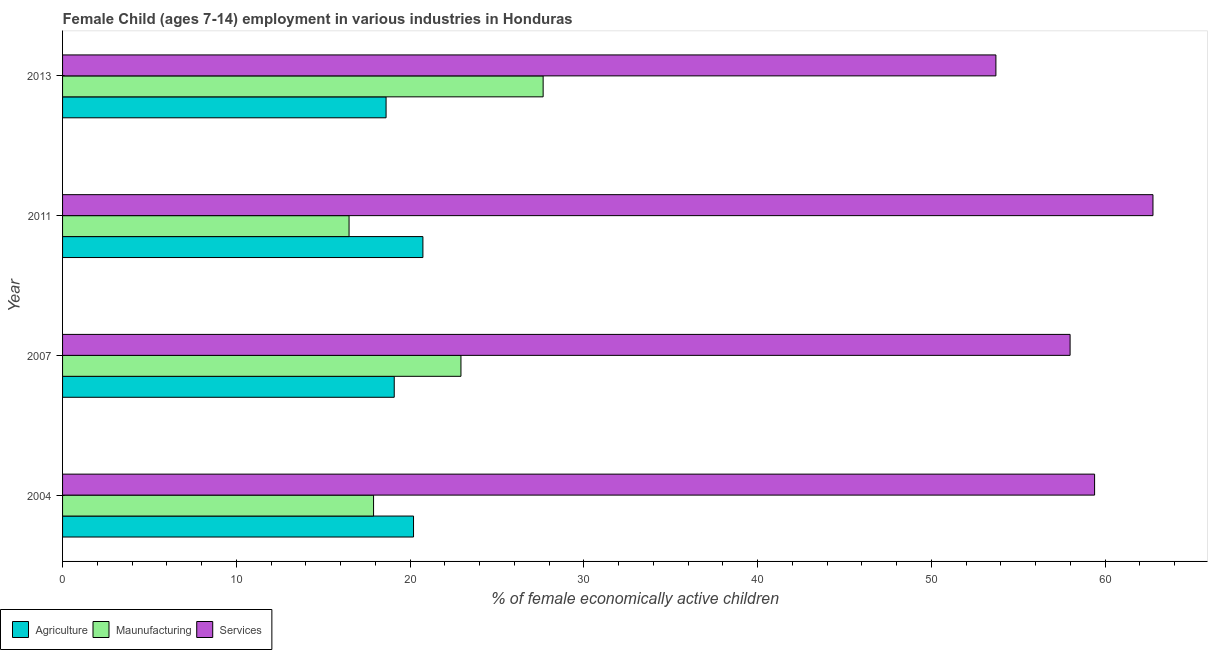How many different coloured bars are there?
Keep it short and to the point. 3. In how many cases, is the number of bars for a given year not equal to the number of legend labels?
Ensure brevity in your answer.  0. What is the percentage of economically active children in services in 2007?
Keep it short and to the point. 57.99. Across all years, what is the maximum percentage of economically active children in agriculture?
Offer a terse response. 20.74. Across all years, what is the minimum percentage of economically active children in agriculture?
Make the answer very short. 18.62. In which year was the percentage of economically active children in manufacturing maximum?
Offer a very short reply. 2013. In which year was the percentage of economically active children in services minimum?
Ensure brevity in your answer.  2013. What is the total percentage of economically active children in services in the graph?
Your answer should be compact. 233.87. What is the difference between the percentage of economically active children in services in 2007 and that in 2011?
Provide a succinct answer. -4.77. What is the difference between the percentage of economically active children in services in 2007 and the percentage of economically active children in manufacturing in 2011?
Keep it short and to the point. 41.5. What is the average percentage of economically active children in manufacturing per year?
Your response must be concise. 21.25. In the year 2007, what is the difference between the percentage of economically active children in agriculture and percentage of economically active children in services?
Give a very brief answer. -38.9. In how many years, is the percentage of economically active children in services greater than 44 %?
Your answer should be compact. 4. What is the ratio of the percentage of economically active children in manufacturing in 2007 to that in 2013?
Your answer should be very brief. 0.83. Is the percentage of economically active children in agriculture in 2011 less than that in 2013?
Provide a short and direct response. No. Is the difference between the percentage of economically active children in agriculture in 2004 and 2011 greater than the difference between the percentage of economically active children in services in 2004 and 2011?
Provide a short and direct response. Yes. What is the difference between the highest and the second highest percentage of economically active children in services?
Provide a short and direct response. 3.36. What is the difference between the highest and the lowest percentage of economically active children in services?
Keep it short and to the point. 9.04. In how many years, is the percentage of economically active children in agriculture greater than the average percentage of economically active children in agriculture taken over all years?
Your answer should be very brief. 2. What does the 2nd bar from the top in 2004 represents?
Provide a short and direct response. Maunufacturing. What does the 3rd bar from the bottom in 2007 represents?
Give a very brief answer. Services. Is it the case that in every year, the sum of the percentage of economically active children in agriculture and percentage of economically active children in manufacturing is greater than the percentage of economically active children in services?
Make the answer very short. No. How many bars are there?
Give a very brief answer. 12. Where does the legend appear in the graph?
Your answer should be compact. Bottom left. How many legend labels are there?
Provide a short and direct response. 3. What is the title of the graph?
Offer a very short reply. Female Child (ages 7-14) employment in various industries in Honduras. What is the label or title of the X-axis?
Keep it short and to the point. % of female economically active children. What is the % of female economically active children in Agriculture in 2004?
Provide a short and direct response. 20.2. What is the % of female economically active children in Services in 2004?
Offer a very short reply. 59.4. What is the % of female economically active children in Agriculture in 2007?
Ensure brevity in your answer.  19.09. What is the % of female economically active children of Maunufacturing in 2007?
Give a very brief answer. 22.93. What is the % of female economically active children in Services in 2007?
Your answer should be compact. 57.99. What is the % of female economically active children of Agriculture in 2011?
Keep it short and to the point. 20.74. What is the % of female economically active children of Maunufacturing in 2011?
Ensure brevity in your answer.  16.49. What is the % of female economically active children of Services in 2011?
Offer a very short reply. 62.76. What is the % of female economically active children of Agriculture in 2013?
Your answer should be compact. 18.62. What is the % of female economically active children in Maunufacturing in 2013?
Offer a very short reply. 27.66. What is the % of female economically active children in Services in 2013?
Ensure brevity in your answer.  53.72. Across all years, what is the maximum % of female economically active children of Agriculture?
Make the answer very short. 20.74. Across all years, what is the maximum % of female economically active children of Maunufacturing?
Offer a terse response. 27.66. Across all years, what is the maximum % of female economically active children in Services?
Your answer should be compact. 62.76. Across all years, what is the minimum % of female economically active children of Agriculture?
Make the answer very short. 18.62. Across all years, what is the minimum % of female economically active children in Maunufacturing?
Offer a very short reply. 16.49. Across all years, what is the minimum % of female economically active children in Services?
Provide a short and direct response. 53.72. What is the total % of female economically active children in Agriculture in the graph?
Give a very brief answer. 78.65. What is the total % of female economically active children in Maunufacturing in the graph?
Offer a terse response. 84.98. What is the total % of female economically active children in Services in the graph?
Offer a very short reply. 233.87. What is the difference between the % of female economically active children in Agriculture in 2004 and that in 2007?
Your response must be concise. 1.11. What is the difference between the % of female economically active children in Maunufacturing in 2004 and that in 2007?
Give a very brief answer. -5.03. What is the difference between the % of female economically active children of Services in 2004 and that in 2007?
Provide a succinct answer. 1.41. What is the difference between the % of female economically active children of Agriculture in 2004 and that in 2011?
Offer a very short reply. -0.54. What is the difference between the % of female economically active children in Maunufacturing in 2004 and that in 2011?
Your answer should be very brief. 1.41. What is the difference between the % of female economically active children of Services in 2004 and that in 2011?
Your answer should be compact. -3.36. What is the difference between the % of female economically active children of Agriculture in 2004 and that in 2013?
Your answer should be compact. 1.58. What is the difference between the % of female economically active children of Maunufacturing in 2004 and that in 2013?
Offer a terse response. -9.76. What is the difference between the % of female economically active children in Services in 2004 and that in 2013?
Make the answer very short. 5.68. What is the difference between the % of female economically active children in Agriculture in 2007 and that in 2011?
Provide a short and direct response. -1.65. What is the difference between the % of female economically active children in Maunufacturing in 2007 and that in 2011?
Ensure brevity in your answer.  6.44. What is the difference between the % of female economically active children in Services in 2007 and that in 2011?
Offer a terse response. -4.77. What is the difference between the % of female economically active children of Agriculture in 2007 and that in 2013?
Ensure brevity in your answer.  0.47. What is the difference between the % of female economically active children of Maunufacturing in 2007 and that in 2013?
Your answer should be very brief. -4.73. What is the difference between the % of female economically active children in Services in 2007 and that in 2013?
Your answer should be very brief. 4.27. What is the difference between the % of female economically active children in Agriculture in 2011 and that in 2013?
Make the answer very short. 2.12. What is the difference between the % of female economically active children of Maunufacturing in 2011 and that in 2013?
Offer a terse response. -11.17. What is the difference between the % of female economically active children of Services in 2011 and that in 2013?
Give a very brief answer. 9.04. What is the difference between the % of female economically active children of Agriculture in 2004 and the % of female economically active children of Maunufacturing in 2007?
Offer a very short reply. -2.73. What is the difference between the % of female economically active children in Agriculture in 2004 and the % of female economically active children in Services in 2007?
Give a very brief answer. -37.79. What is the difference between the % of female economically active children in Maunufacturing in 2004 and the % of female economically active children in Services in 2007?
Keep it short and to the point. -40.09. What is the difference between the % of female economically active children of Agriculture in 2004 and the % of female economically active children of Maunufacturing in 2011?
Make the answer very short. 3.71. What is the difference between the % of female economically active children in Agriculture in 2004 and the % of female economically active children in Services in 2011?
Ensure brevity in your answer.  -42.56. What is the difference between the % of female economically active children in Maunufacturing in 2004 and the % of female economically active children in Services in 2011?
Make the answer very short. -44.86. What is the difference between the % of female economically active children in Agriculture in 2004 and the % of female economically active children in Maunufacturing in 2013?
Your answer should be compact. -7.46. What is the difference between the % of female economically active children of Agriculture in 2004 and the % of female economically active children of Services in 2013?
Offer a very short reply. -33.52. What is the difference between the % of female economically active children of Maunufacturing in 2004 and the % of female economically active children of Services in 2013?
Provide a short and direct response. -35.82. What is the difference between the % of female economically active children of Agriculture in 2007 and the % of female economically active children of Maunufacturing in 2011?
Keep it short and to the point. 2.6. What is the difference between the % of female economically active children of Agriculture in 2007 and the % of female economically active children of Services in 2011?
Offer a terse response. -43.67. What is the difference between the % of female economically active children of Maunufacturing in 2007 and the % of female economically active children of Services in 2011?
Your response must be concise. -39.83. What is the difference between the % of female economically active children in Agriculture in 2007 and the % of female economically active children in Maunufacturing in 2013?
Keep it short and to the point. -8.57. What is the difference between the % of female economically active children of Agriculture in 2007 and the % of female economically active children of Services in 2013?
Your answer should be compact. -34.63. What is the difference between the % of female economically active children in Maunufacturing in 2007 and the % of female economically active children in Services in 2013?
Provide a short and direct response. -30.79. What is the difference between the % of female economically active children of Agriculture in 2011 and the % of female economically active children of Maunufacturing in 2013?
Provide a short and direct response. -6.92. What is the difference between the % of female economically active children in Agriculture in 2011 and the % of female economically active children in Services in 2013?
Provide a short and direct response. -32.98. What is the difference between the % of female economically active children in Maunufacturing in 2011 and the % of female economically active children in Services in 2013?
Offer a terse response. -37.23. What is the average % of female economically active children of Agriculture per year?
Offer a terse response. 19.66. What is the average % of female economically active children in Maunufacturing per year?
Provide a succinct answer. 21.25. What is the average % of female economically active children of Services per year?
Provide a succinct answer. 58.47. In the year 2004, what is the difference between the % of female economically active children in Agriculture and % of female economically active children in Maunufacturing?
Provide a succinct answer. 2.3. In the year 2004, what is the difference between the % of female economically active children in Agriculture and % of female economically active children in Services?
Ensure brevity in your answer.  -39.2. In the year 2004, what is the difference between the % of female economically active children in Maunufacturing and % of female economically active children in Services?
Make the answer very short. -41.5. In the year 2007, what is the difference between the % of female economically active children of Agriculture and % of female economically active children of Maunufacturing?
Keep it short and to the point. -3.84. In the year 2007, what is the difference between the % of female economically active children in Agriculture and % of female economically active children in Services?
Your answer should be compact. -38.9. In the year 2007, what is the difference between the % of female economically active children in Maunufacturing and % of female economically active children in Services?
Keep it short and to the point. -35.06. In the year 2011, what is the difference between the % of female economically active children of Agriculture and % of female economically active children of Maunufacturing?
Offer a very short reply. 4.25. In the year 2011, what is the difference between the % of female economically active children of Agriculture and % of female economically active children of Services?
Offer a terse response. -42.02. In the year 2011, what is the difference between the % of female economically active children of Maunufacturing and % of female economically active children of Services?
Offer a very short reply. -46.27. In the year 2013, what is the difference between the % of female economically active children of Agriculture and % of female economically active children of Maunufacturing?
Your answer should be very brief. -9.04. In the year 2013, what is the difference between the % of female economically active children of Agriculture and % of female economically active children of Services?
Give a very brief answer. -35.1. In the year 2013, what is the difference between the % of female economically active children in Maunufacturing and % of female economically active children in Services?
Your answer should be compact. -26.06. What is the ratio of the % of female economically active children of Agriculture in 2004 to that in 2007?
Make the answer very short. 1.06. What is the ratio of the % of female economically active children in Maunufacturing in 2004 to that in 2007?
Your answer should be very brief. 0.78. What is the ratio of the % of female economically active children of Services in 2004 to that in 2007?
Provide a succinct answer. 1.02. What is the ratio of the % of female economically active children of Agriculture in 2004 to that in 2011?
Your response must be concise. 0.97. What is the ratio of the % of female economically active children in Maunufacturing in 2004 to that in 2011?
Make the answer very short. 1.09. What is the ratio of the % of female economically active children of Services in 2004 to that in 2011?
Your answer should be very brief. 0.95. What is the ratio of the % of female economically active children of Agriculture in 2004 to that in 2013?
Your answer should be very brief. 1.08. What is the ratio of the % of female economically active children of Maunufacturing in 2004 to that in 2013?
Your answer should be compact. 0.65. What is the ratio of the % of female economically active children of Services in 2004 to that in 2013?
Offer a very short reply. 1.11. What is the ratio of the % of female economically active children of Agriculture in 2007 to that in 2011?
Keep it short and to the point. 0.92. What is the ratio of the % of female economically active children in Maunufacturing in 2007 to that in 2011?
Make the answer very short. 1.39. What is the ratio of the % of female economically active children of Services in 2007 to that in 2011?
Keep it short and to the point. 0.92. What is the ratio of the % of female economically active children of Agriculture in 2007 to that in 2013?
Give a very brief answer. 1.03. What is the ratio of the % of female economically active children of Maunufacturing in 2007 to that in 2013?
Offer a very short reply. 0.83. What is the ratio of the % of female economically active children of Services in 2007 to that in 2013?
Give a very brief answer. 1.08. What is the ratio of the % of female economically active children in Agriculture in 2011 to that in 2013?
Give a very brief answer. 1.11. What is the ratio of the % of female economically active children in Maunufacturing in 2011 to that in 2013?
Give a very brief answer. 0.6. What is the ratio of the % of female economically active children in Services in 2011 to that in 2013?
Ensure brevity in your answer.  1.17. What is the difference between the highest and the second highest % of female economically active children of Agriculture?
Your response must be concise. 0.54. What is the difference between the highest and the second highest % of female economically active children of Maunufacturing?
Provide a succinct answer. 4.73. What is the difference between the highest and the second highest % of female economically active children of Services?
Provide a short and direct response. 3.36. What is the difference between the highest and the lowest % of female economically active children of Agriculture?
Keep it short and to the point. 2.12. What is the difference between the highest and the lowest % of female economically active children in Maunufacturing?
Give a very brief answer. 11.17. What is the difference between the highest and the lowest % of female economically active children of Services?
Your response must be concise. 9.04. 